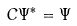<formula> <loc_0><loc_0><loc_500><loc_500>C \Psi ^ { \ast } = \Psi</formula> 